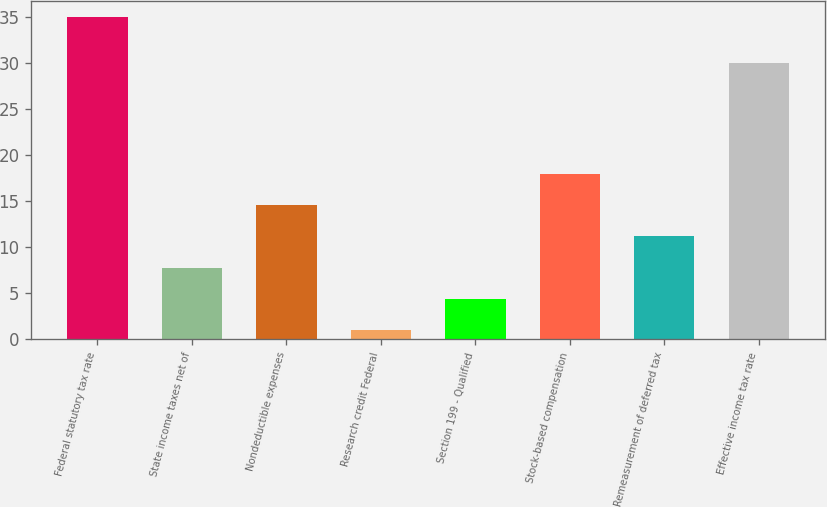Convert chart to OTSL. <chart><loc_0><loc_0><loc_500><loc_500><bar_chart><fcel>Federal statutory tax rate<fcel>State income taxes net of<fcel>Nondeductible expenses<fcel>Research credit Federal<fcel>Section 199 - Qualified<fcel>Stock-based compensation<fcel>Remeasurement of deferred tax<fcel>Effective income tax rate<nl><fcel>35<fcel>7.8<fcel>14.6<fcel>1<fcel>4.4<fcel>18<fcel>11.2<fcel>30<nl></chart> 